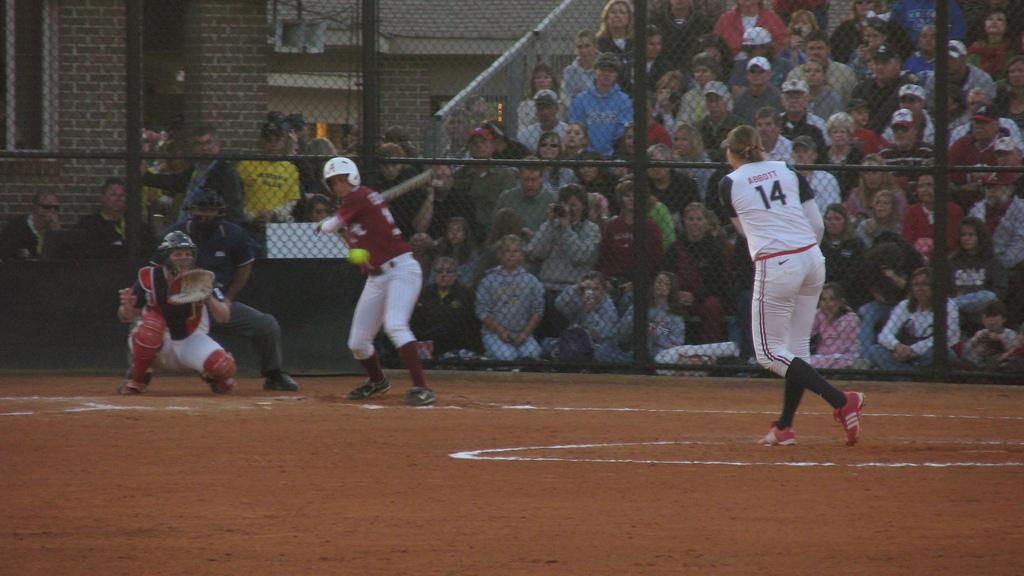<image>
Present a compact description of the photo's key features. Player 14 has just pitched the ball to the other team. 